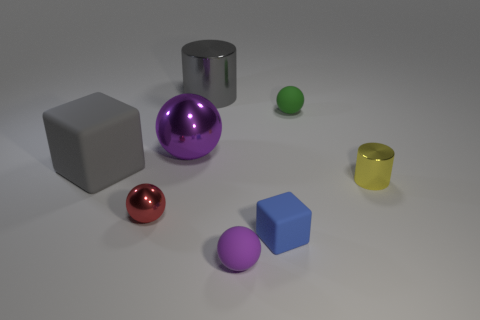There is a blue matte cube that is on the right side of the shiny sphere that is behind the yellow metallic cylinder; what number of matte cubes are in front of it?
Provide a short and direct response. 0. There is a purple ball in front of the blue block; is it the same size as the small cylinder?
Provide a short and direct response. Yes. Is the number of gray cylinders that are in front of the tiny blue rubber thing less than the number of big matte objects that are in front of the small red ball?
Provide a succinct answer. No. Is the color of the big rubber thing the same as the big cylinder?
Provide a short and direct response. Yes. Are there fewer green objects on the right side of the purple metal ball than tiny blue matte blocks?
Provide a short and direct response. No. What is the material of the block that is the same color as the big metallic cylinder?
Keep it short and to the point. Rubber. Are the large block and the small cube made of the same material?
Your answer should be compact. Yes. What number of small purple balls are made of the same material as the big cube?
Provide a succinct answer. 1. What color is the large ball that is made of the same material as the gray cylinder?
Provide a succinct answer. Purple. What is the shape of the big rubber thing?
Ensure brevity in your answer.  Cube. 